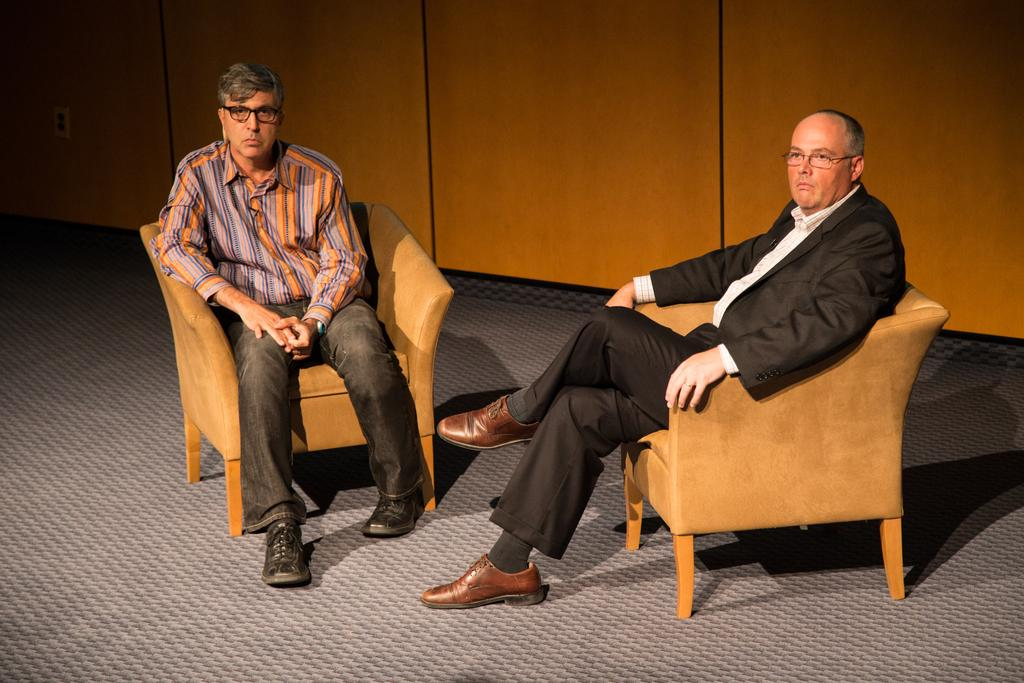How many people are in the image? There are two people in the image. What are the people doing in the image? The people are sitting in a brown chair. What color is the carpet beneath the chair? The carpet beneath the chair is grey. What color is the wall in the background of the image? The wall in the background of the image is brown. How many bikes are parked near the people in the image? There are no bikes present in the image. What type of party is taking place in the image? There is no party depicted in the image. 